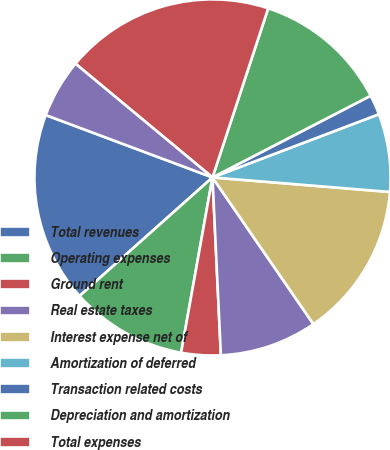<chart> <loc_0><loc_0><loc_500><loc_500><pie_chart><fcel>Total revenues<fcel>Operating expenses<fcel>Ground rent<fcel>Real estate taxes<fcel>Interest expense net of<fcel>Amortization of deferred<fcel>Transaction related costs<fcel>Depreciation and amortization<fcel>Total expenses<fcel>Net income (loss) before gain<nl><fcel>17.29%<fcel>10.59%<fcel>3.57%<fcel>8.84%<fcel>14.11%<fcel>7.08%<fcel>1.81%<fcel>12.35%<fcel>19.04%<fcel>5.33%<nl></chart> 